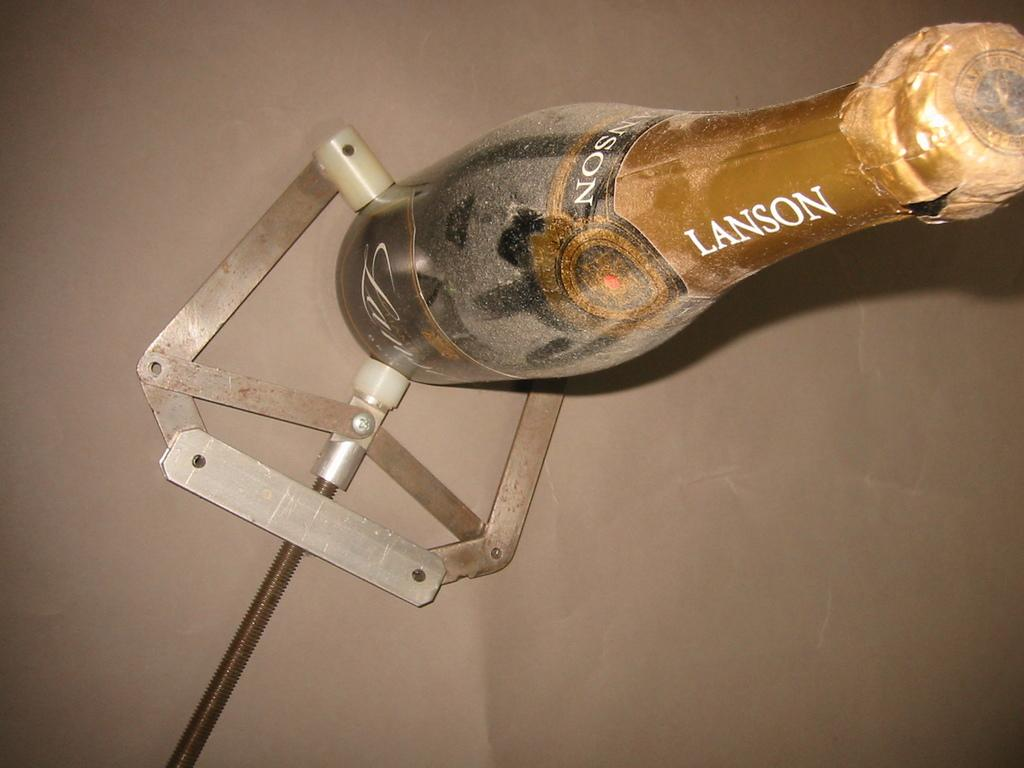Provide a one-sentence caption for the provided image. A dusty bottle of Lanson champagne is held by a special metal device. 